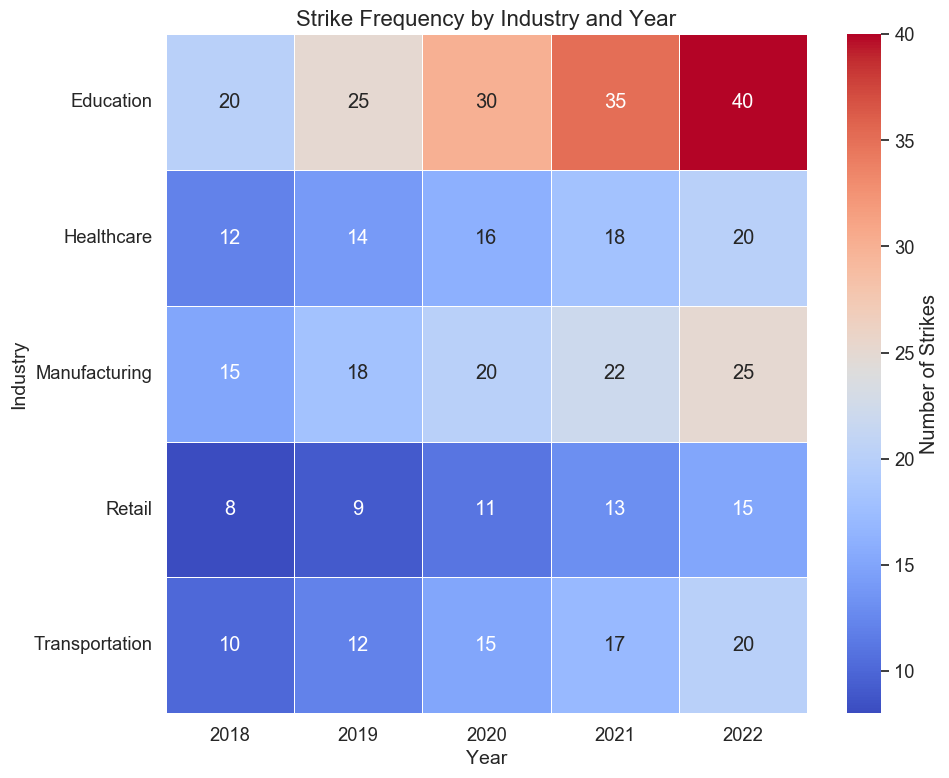Which industry had the highest number of strikes in 2022? Look for the data in the 2022 column. Education has the highest value at 40 strikes.
Answer: Education How did the number of strikes in the healthcare industry change from 2018 to 2022? Compare the values for healthcare between 2018 and 2022. In 2018 it was 12 strikes, and in 2022 it was 20 strikes, showing an increase of 8 strikes.
Answer: Increased by 8 Which year had the overall highest frequency of strikes in the manufacturing industry? Look at the Manufacturing row across all years. The highest value appears in 2022 with 25 strikes.
Answer: 2022 How many more strikes did the retail industry have in 2022 compared to 2018? Subtract the value for retail in 2018 (8 strikes) from the value in 2022 (15 strikes). The result is 7 more strikes in 2022.
Answer: 7 more In which year did the transportation industry experience the fewest strikes? Check the Transportation row for the smallest value across all years. The lowest value is 10 strikes in 2018.
Answer: 2018 Which industry experienced the most consistent increase in strikes each year from 2018 to 2022? Compare the values for each industry over the years. The Education industry shows a consistent increase: 20 (2018), 25 (2019), 30 (2020), 35 (2021), 40 (2022).
Answer: Education What is the average number of strikes in the healthcare industry across all years displayed? Add the number of strikes for Healthcare across all years (12, 14, 16, 18, 20) = 80 strikes. Divide by 5 years to get an average.
Answer: 16 Considering both manufacturing and transportation industries, which had more total strikes from 2018 to 2022? Sum up the number of strikes for both industries across all years: Manufacturing (15+18+20+22+25) = 100; Transportation (10+12+15+17+20) = 74. Manufacturing had more.
Answer: Manufacturing If we sum the number of strikes in Education for 2018, 2020, and 2022, what is the total? Add the number of strikes for Education in 2018 (20), 2020 (30), and 2022 (40). The total is 20 + 30 + 40 = 90 strikes.
Answer: 90 By how much did the number of strikes in the Manufacturing industry differ between the year with the highest and the year with the lowest strikes? The highest value in Manufacturing is 25 (2022) and the lowest is 15 (2018), so the difference is 25 - 15 = 10 strikes.
Answer: 10 